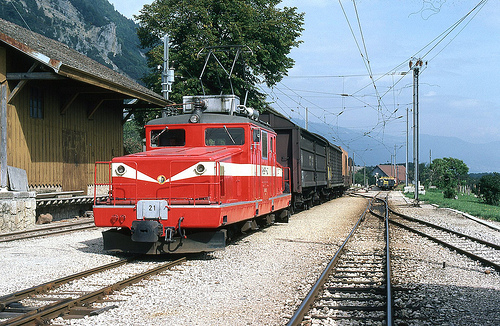How large are the rocks? The rocks along the railway tracks are medium-sized, suitable for supporting the track structure. 